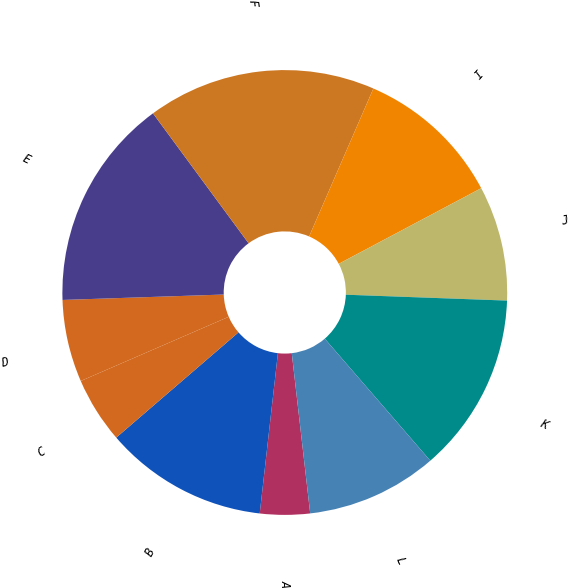<chart> <loc_0><loc_0><loc_500><loc_500><pie_chart><fcel>A<fcel>B<fcel>C<fcel>D<fcel>E<fcel>F<fcel>I<fcel>J<fcel>K<fcel>L<nl><fcel>3.62%<fcel>11.89%<fcel>4.8%<fcel>5.98%<fcel>15.44%<fcel>16.62%<fcel>10.71%<fcel>8.35%<fcel>13.07%<fcel>9.53%<nl></chart> 